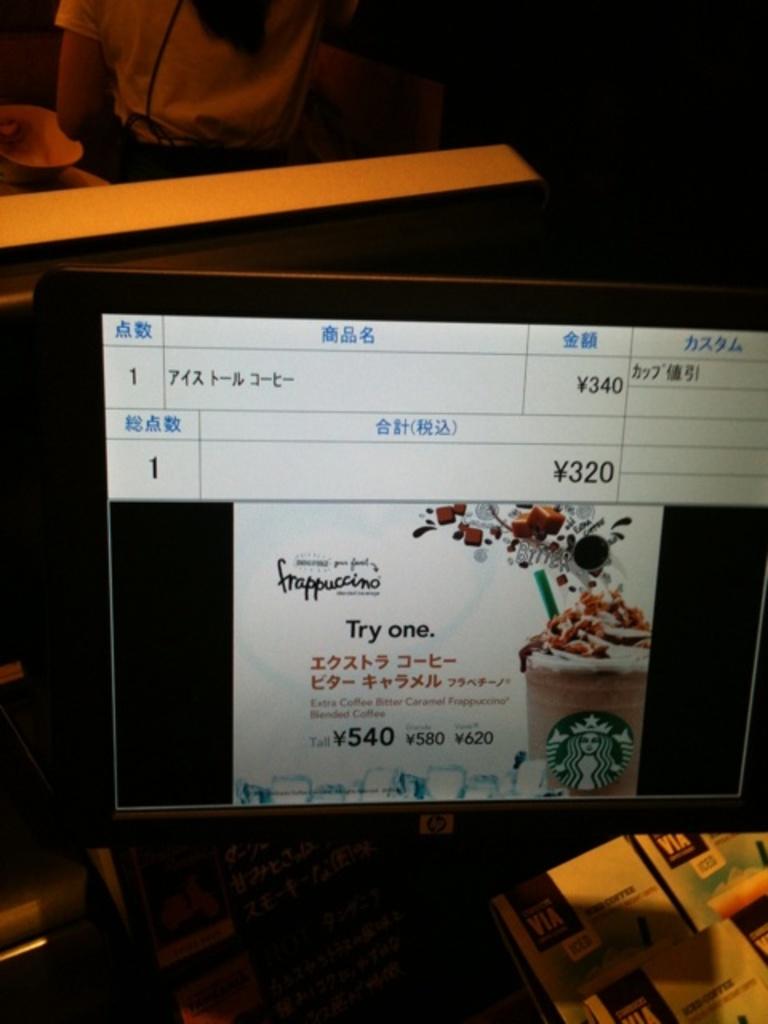How much does the tall frappuccino cost?
Ensure brevity in your answer.  540. 